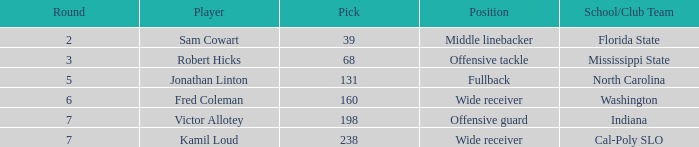Which Round has a School/Club Team of cal-poly slo, and a Pick smaller than 238? None. Help me parse the entirety of this table. {'header': ['Round', 'Player', 'Pick', 'Position', 'School/Club Team'], 'rows': [['2', 'Sam Cowart', '39', 'Middle linebacker', 'Florida State'], ['3', 'Robert Hicks', '68', 'Offensive tackle', 'Mississippi State'], ['5', 'Jonathan Linton', '131', 'Fullback', 'North Carolina'], ['6', 'Fred Coleman', '160', 'Wide receiver', 'Washington'], ['7', 'Victor Allotey', '198', 'Offensive guard', 'Indiana'], ['7', 'Kamil Loud', '238', 'Wide receiver', 'Cal-Poly SLO']]} 